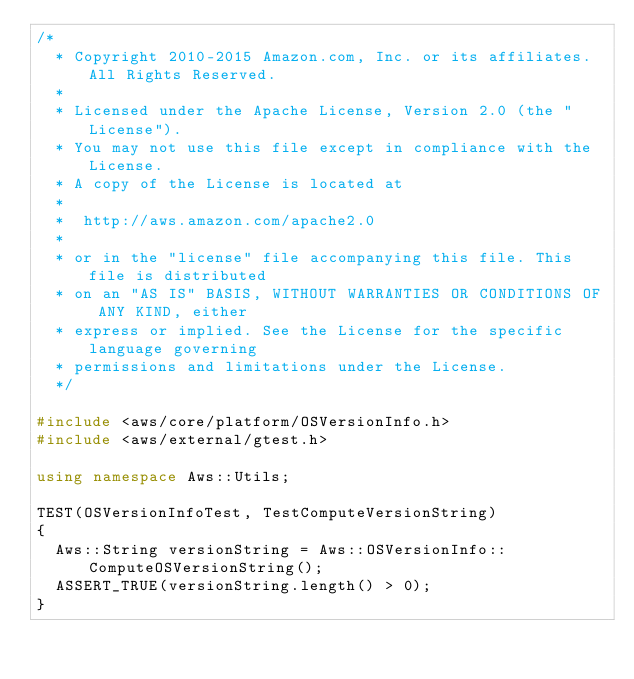<code> <loc_0><loc_0><loc_500><loc_500><_C++_>/*
  * Copyright 2010-2015 Amazon.com, Inc. or its affiliates. All Rights Reserved.
  *
  * Licensed under the Apache License, Version 2.0 (the "License").
  * You may not use this file except in compliance with the License.
  * A copy of the License is located at
  *
  *  http://aws.amazon.com/apache2.0
  *
  * or in the "license" file accompanying this file. This file is distributed
  * on an "AS IS" BASIS, WITHOUT WARRANTIES OR CONDITIONS OF ANY KIND, either
  * express or implied. See the License for the specific language governing
  * permissions and limitations under the License.
  */

#include <aws/core/platform/OSVersionInfo.h>
#include <aws/external/gtest.h>

using namespace Aws::Utils;

TEST(OSVersionInfoTest, TestComputeVersionString)
{
  Aws::String versionString = Aws::OSVersionInfo::ComputeOSVersionString();
  ASSERT_TRUE(versionString.length() > 0);
}

</code> 